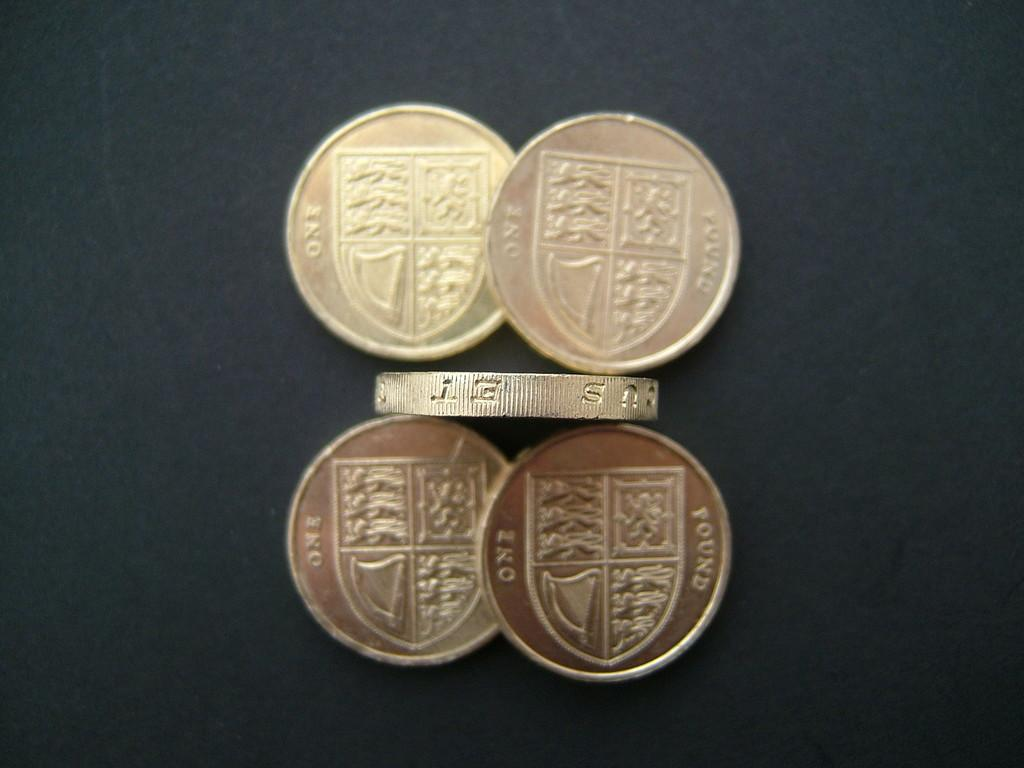<image>
Summarize the visual content of the image. Five golden coins on a table that say, one pound. 